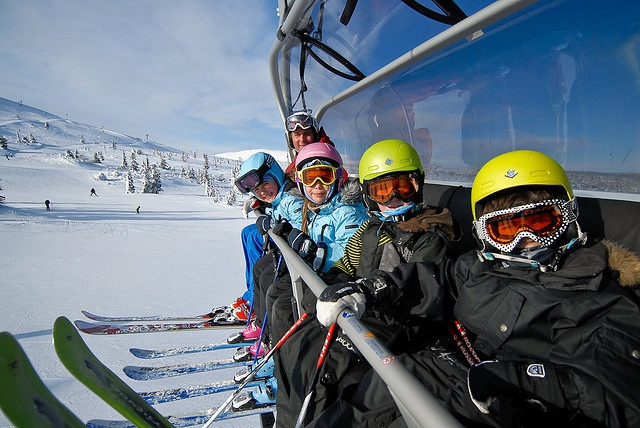Describe the objects in this image and their specific colors. I can see people in gray, black, gold, and white tones, skis in gray, black, darkgreen, and darkgray tones, people in gray, black, darkgreen, and maroon tones, people in gray, black, lightblue, and white tones, and people in gray, black, blue, and lightgray tones in this image. 